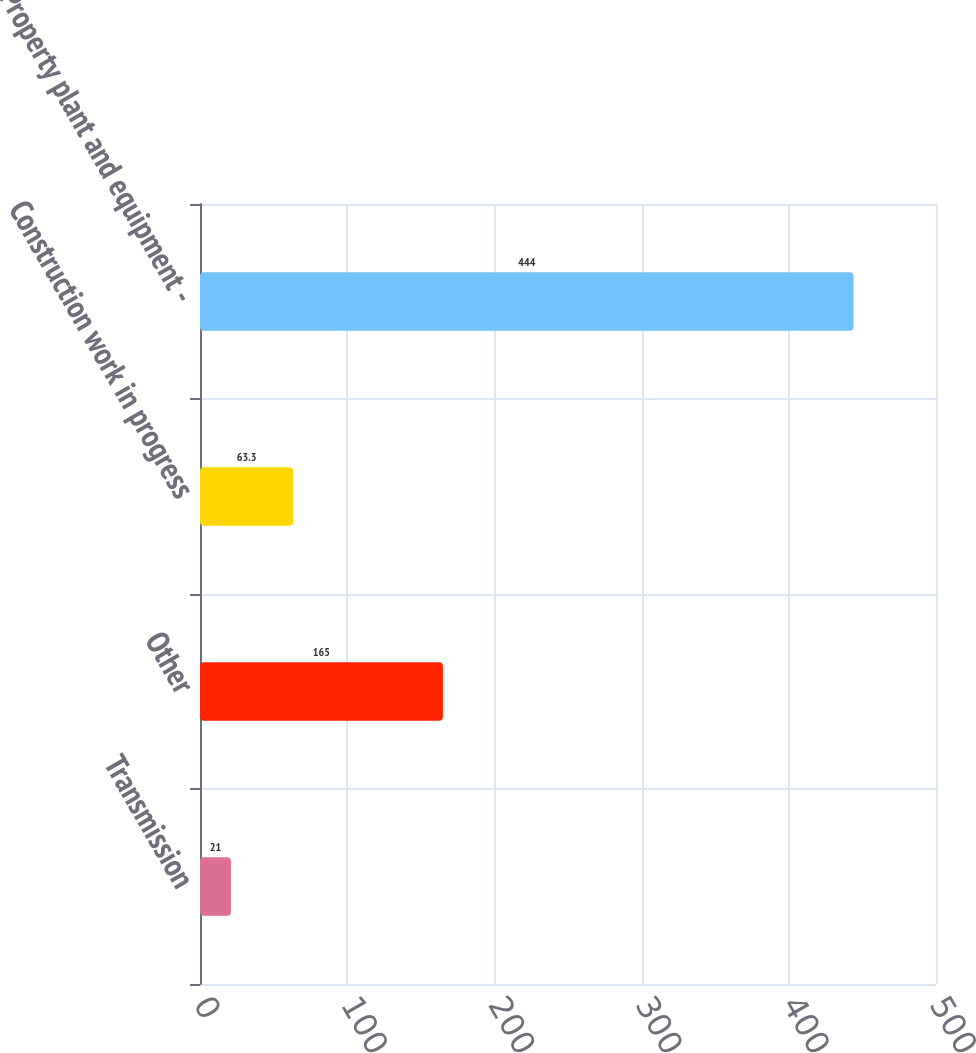Convert chart to OTSL. <chart><loc_0><loc_0><loc_500><loc_500><bar_chart><fcel>Transmission<fcel>Other<fcel>Construction work in progress<fcel>Property plant and equipment -<nl><fcel>21<fcel>165<fcel>63.3<fcel>444<nl></chart> 